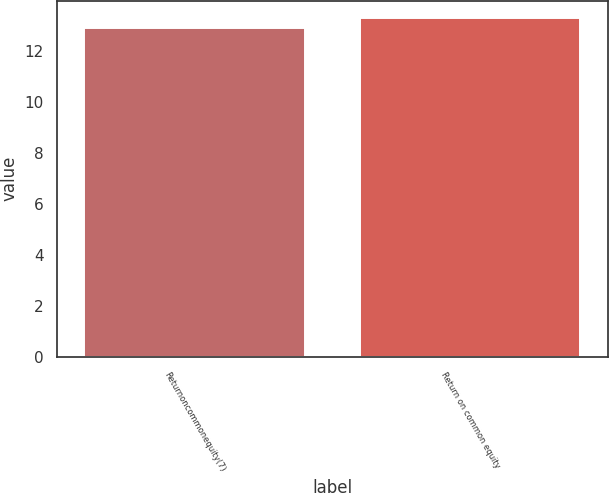<chart> <loc_0><loc_0><loc_500><loc_500><bar_chart><fcel>Returnoncommonequity(7)<fcel>Return on common equity<nl><fcel>12.9<fcel>13.3<nl></chart> 